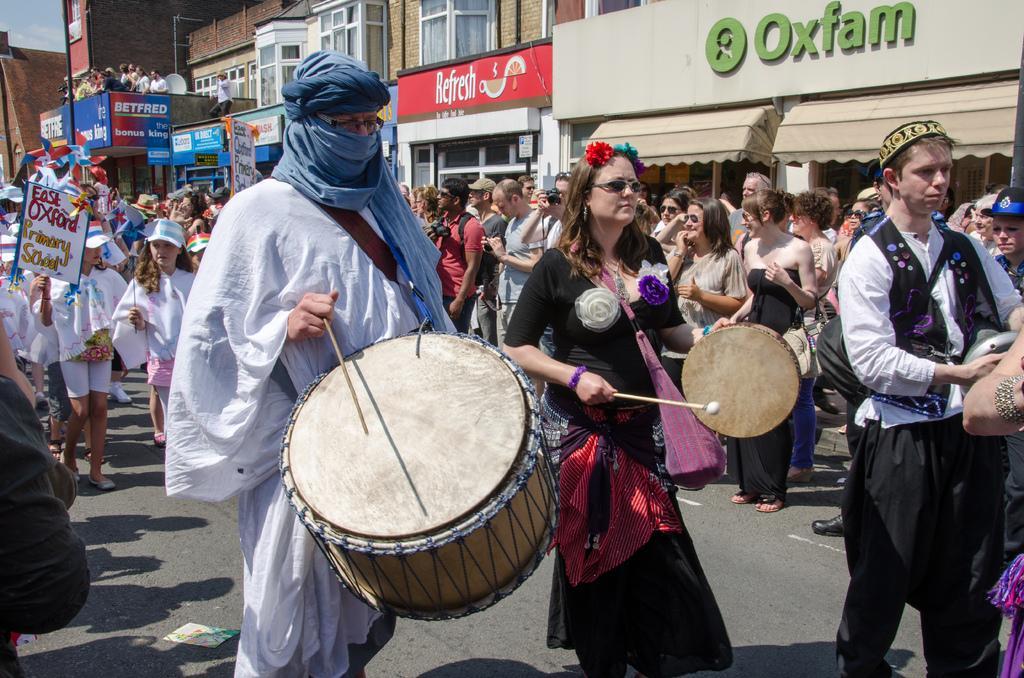Can you describe this image briefly? There are some people walking on the road with drums in their hands. There is a man and a woman The man is holding the big drum and the woman is holding the small drum. The is wearing a spectacles and a cloth around his face. There are some children behind them walking with a boards in their hands. In the background we can observe some buildings and a red colored board here. 